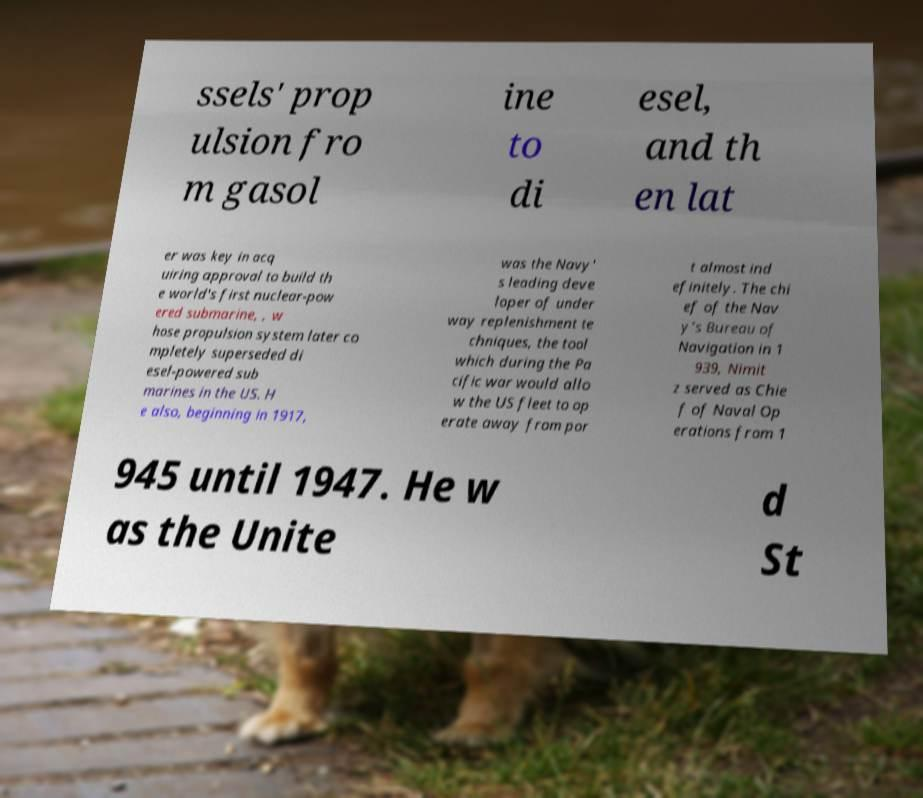There's text embedded in this image that I need extracted. Can you transcribe it verbatim? ssels' prop ulsion fro m gasol ine to di esel, and th en lat er was key in acq uiring approval to build th e world's first nuclear-pow ered submarine, , w hose propulsion system later co mpletely superseded di esel-powered sub marines in the US. H e also, beginning in 1917, was the Navy' s leading deve loper of under way replenishment te chniques, the tool which during the Pa cific war would allo w the US fleet to op erate away from por t almost ind efinitely. The chi ef of the Nav y's Bureau of Navigation in 1 939, Nimit z served as Chie f of Naval Op erations from 1 945 until 1947. He w as the Unite d St 